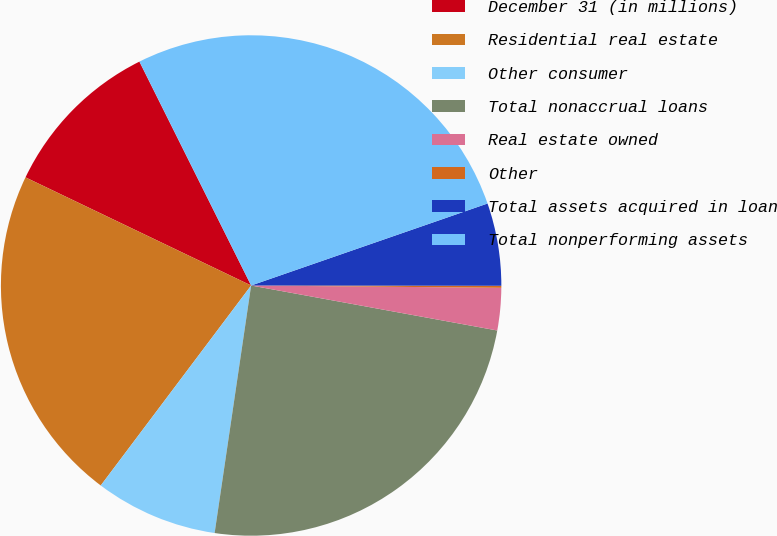<chart> <loc_0><loc_0><loc_500><loc_500><pie_chart><fcel>December 31 (in millions)<fcel>Residential real estate<fcel>Other consumer<fcel>Total nonaccrual loans<fcel>Real estate owned<fcel>Other<fcel>Total assets acquired in loan<fcel>Total nonperforming assets<nl><fcel>10.52%<fcel>21.85%<fcel>7.93%<fcel>24.45%<fcel>2.73%<fcel>0.13%<fcel>5.33%<fcel>27.05%<nl></chart> 